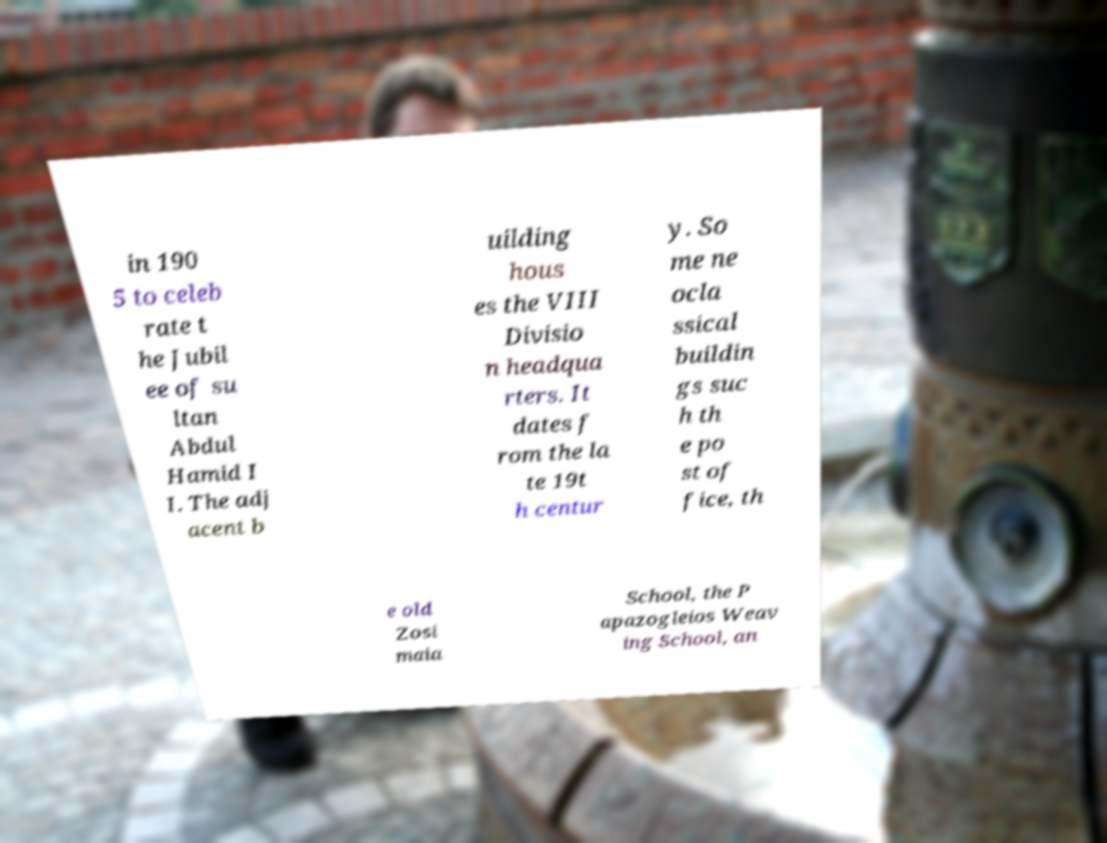Please read and relay the text visible in this image. What does it say? in 190 5 to celeb rate t he Jubil ee of su ltan Abdul Hamid I I. The adj acent b uilding hous es the VIII Divisio n headqua rters. It dates f rom the la te 19t h centur y. So me ne ocla ssical buildin gs suc h th e po st of fice, th e old Zosi maia School, the P apazogleios Weav ing School, an 